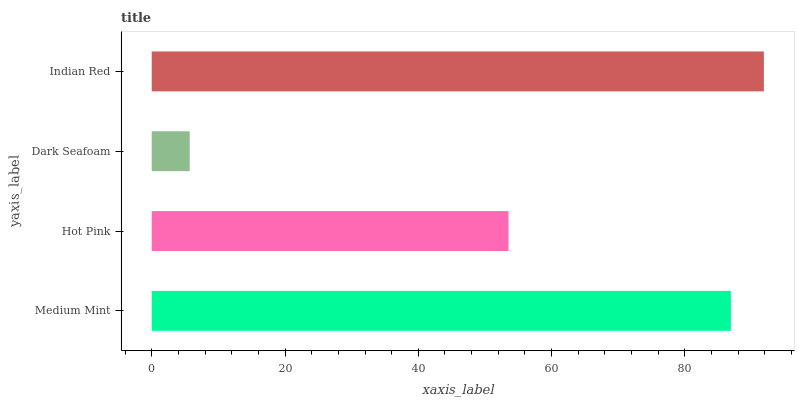Is Dark Seafoam the minimum?
Answer yes or no. Yes. Is Indian Red the maximum?
Answer yes or no. Yes. Is Hot Pink the minimum?
Answer yes or no. No. Is Hot Pink the maximum?
Answer yes or no. No. Is Medium Mint greater than Hot Pink?
Answer yes or no. Yes. Is Hot Pink less than Medium Mint?
Answer yes or no. Yes. Is Hot Pink greater than Medium Mint?
Answer yes or no. No. Is Medium Mint less than Hot Pink?
Answer yes or no. No. Is Medium Mint the high median?
Answer yes or no. Yes. Is Hot Pink the low median?
Answer yes or no. Yes. Is Indian Red the high median?
Answer yes or no. No. Is Dark Seafoam the low median?
Answer yes or no. No. 